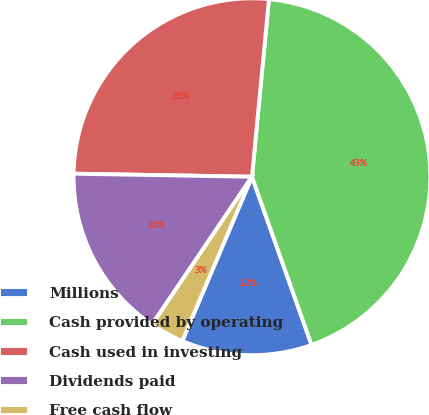Convert chart to OTSL. <chart><loc_0><loc_0><loc_500><loc_500><pie_chart><fcel>Millions<fcel>Cash provided by operating<fcel>Cash used in investing<fcel>Dividends paid<fcel>Free cash flow<nl><fcel>11.81%<fcel>43.06%<fcel>26.24%<fcel>15.81%<fcel>3.07%<nl></chart> 